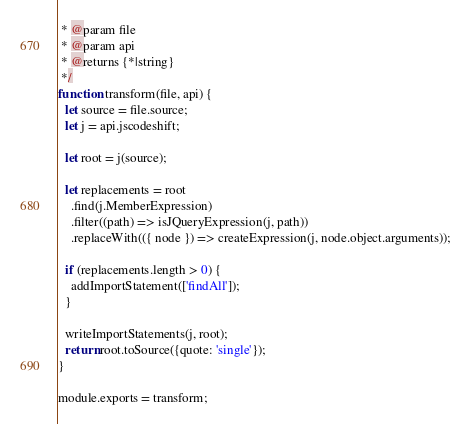<code> <loc_0><loc_0><loc_500><loc_500><_JavaScript_> * @param file
 * @param api
 * @returns {*|string}
 */
function transform(file, api) {
  let source = file.source;
  let j = api.jscodeshift;

  let root = j(source);

  let replacements = root
    .find(j.MemberExpression)
    .filter((path) => isJQueryExpression(j, path))
    .replaceWith(({ node }) => createExpression(j, node.object.arguments));

  if (replacements.length > 0) {
    addImportStatement(['findAll']);
  }

  writeImportStatements(j, root);
  return root.toSource({quote: 'single'});
}

module.exports = transform;
</code> 